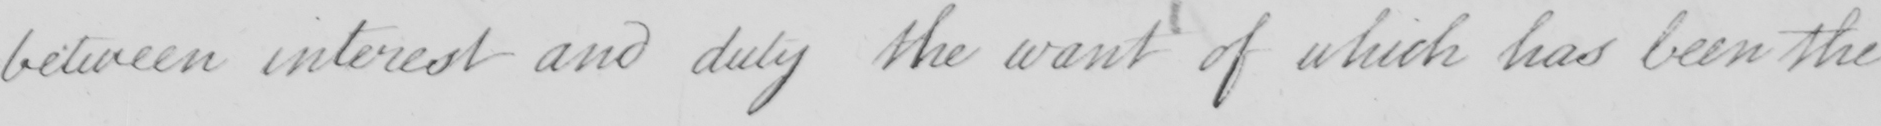Can you read and transcribe this handwriting? between interest and duty the want of which has been the 